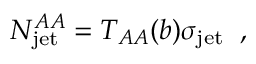Convert formula to latex. <formula><loc_0><loc_0><loc_500><loc_500>N _ { j e t } ^ { A A } = T _ { A A } ( b ) \sigma _ { j e t } \, ,</formula> 